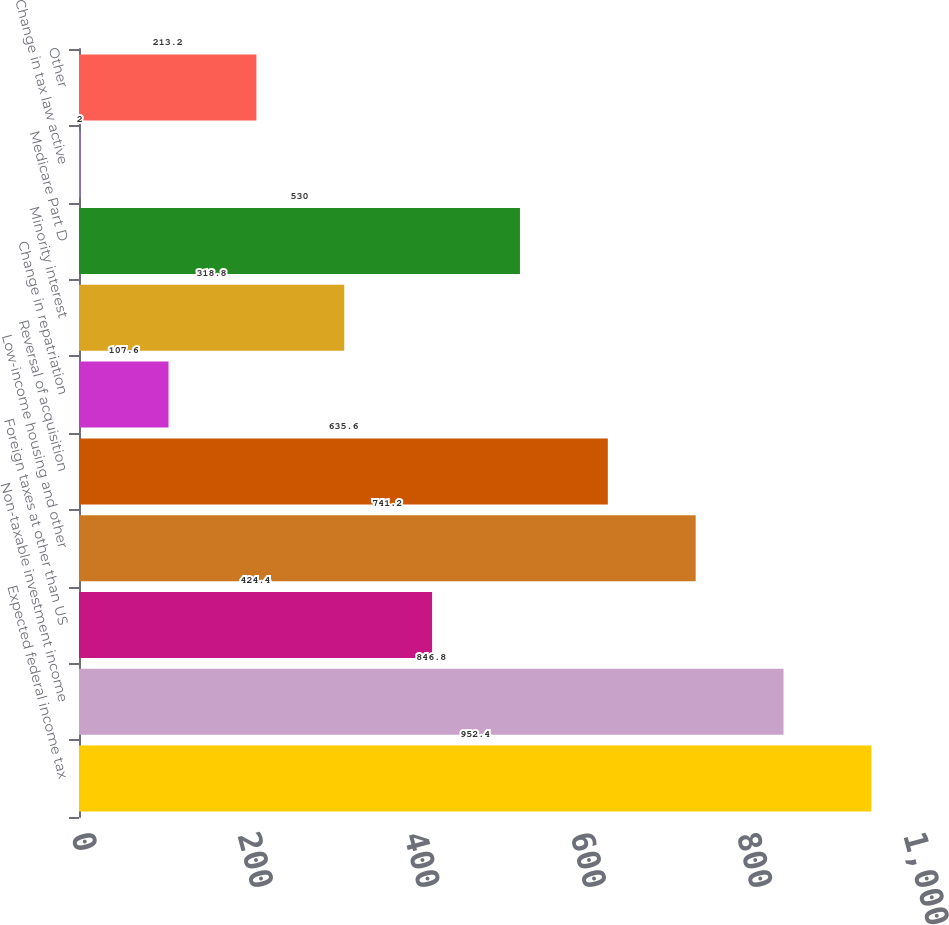<chart> <loc_0><loc_0><loc_500><loc_500><bar_chart><fcel>Expected federal income tax<fcel>Non-taxable investment income<fcel>Foreign taxes at other than US<fcel>Low-income housing and other<fcel>Reversal of acquisition<fcel>Change in repatriation<fcel>Minority interest<fcel>Medicare Part D<fcel>Change in tax law active<fcel>Other<nl><fcel>952.4<fcel>846.8<fcel>424.4<fcel>741.2<fcel>635.6<fcel>107.6<fcel>318.8<fcel>530<fcel>2<fcel>213.2<nl></chart> 